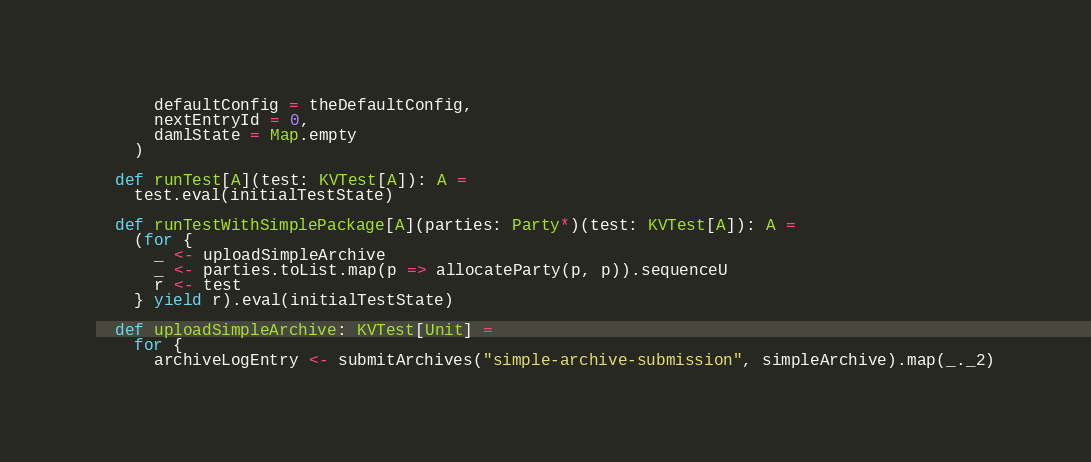Convert code to text. <code><loc_0><loc_0><loc_500><loc_500><_Scala_>      defaultConfig = theDefaultConfig,
      nextEntryId = 0,
      damlState = Map.empty
    )

  def runTest[A](test: KVTest[A]): A =
    test.eval(initialTestState)

  def runTestWithSimplePackage[A](parties: Party*)(test: KVTest[A]): A =
    (for {
      _ <- uploadSimpleArchive
      _ <- parties.toList.map(p => allocateParty(p, p)).sequenceU
      r <- test
    } yield r).eval(initialTestState)

  def uploadSimpleArchive: KVTest[Unit] =
    for {
      archiveLogEntry <- submitArchives("simple-archive-submission", simpleArchive).map(_._2)</code> 